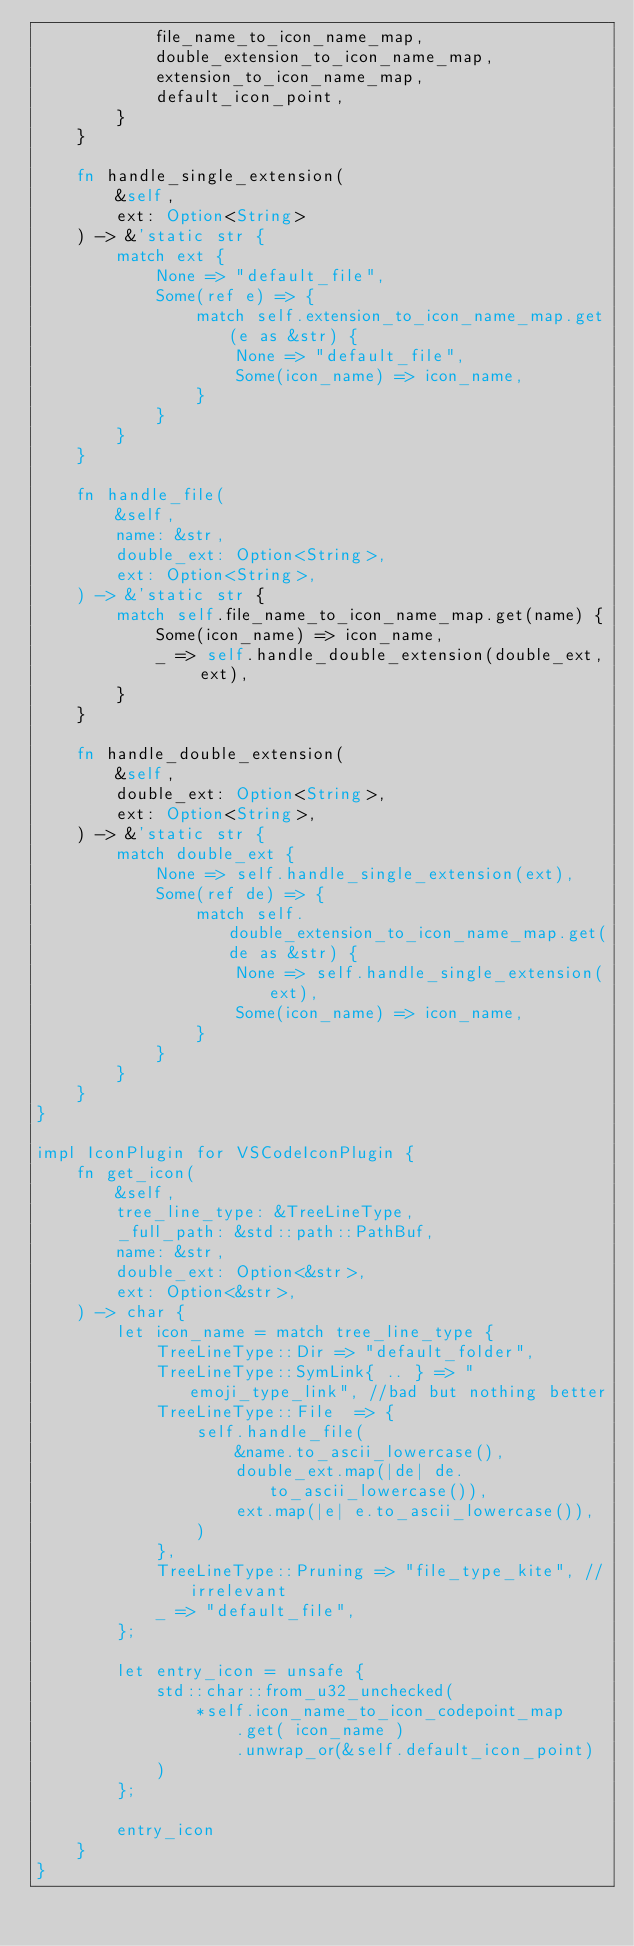Convert code to text. <code><loc_0><loc_0><loc_500><loc_500><_Rust_>            file_name_to_icon_name_map,
            double_extension_to_icon_name_map,
            extension_to_icon_name_map,
            default_icon_point,
        }
    }

    fn handle_single_extension(
        &self,
        ext: Option<String>
    ) -> &'static str {
        match ext {
            None => "default_file",
            Some(ref e) => {
                match self.extension_to_icon_name_map.get(e as &str) {
                    None => "default_file",
                    Some(icon_name) => icon_name,
                }
            }
        }
    }

    fn handle_file(
        &self,
        name: &str,
        double_ext: Option<String>,
        ext: Option<String>,
    ) -> &'static str {
        match self.file_name_to_icon_name_map.get(name) {
            Some(icon_name) => icon_name,
            _ => self.handle_double_extension(double_ext, ext),
        }
    }

    fn handle_double_extension(
        &self,
        double_ext: Option<String>,
        ext: Option<String>,
    ) -> &'static str {
        match double_ext {
            None => self.handle_single_extension(ext),
            Some(ref de) => {
                match self.double_extension_to_icon_name_map.get(de as &str) {
                    None => self.handle_single_extension(ext),
                    Some(icon_name) => icon_name,
                }
            }
        }
    }
}

impl IconPlugin for VSCodeIconPlugin {
    fn get_icon(
        &self,
        tree_line_type: &TreeLineType,
        _full_path: &std::path::PathBuf,
        name: &str,
        double_ext: Option<&str>,
        ext: Option<&str>,
    ) -> char {
        let icon_name = match tree_line_type {
            TreeLineType::Dir => "default_folder",
            TreeLineType::SymLink{ .. } => "emoji_type_link", //bad but nothing better
            TreeLineType::File  => {
                self.handle_file(
                    &name.to_ascii_lowercase(),
                    double_ext.map(|de| de.to_ascii_lowercase()),
                    ext.map(|e| e.to_ascii_lowercase()),
                )
            },
            TreeLineType::Pruning => "file_type_kite", //irrelevant
            _ => "default_file",
        };

        let entry_icon = unsafe {
            std::char::from_u32_unchecked(
                *self.icon_name_to_icon_codepoint_map
                    .get( icon_name )
                    .unwrap_or(&self.default_icon_point)
            )
        };

        entry_icon
    }
}
</code> 